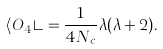Convert formula to latex. <formula><loc_0><loc_0><loc_500><loc_500>\langle O _ { 4 } \rangle = \frac { 1 } { 4 N _ { c } } \lambda ( \lambda + 2 ) .</formula> 